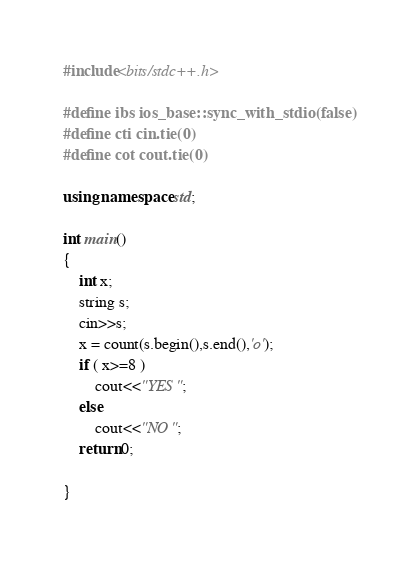<code> <loc_0><loc_0><loc_500><loc_500><_C++_>#include<bits/stdc++.h>

#define ibs ios_base::sync_with_stdio(false)
#define cti cin.tie(0)
#define cot cout.tie(0)

using namespace std;

int main()
{
    int x;
	string s;
    cin>>s;
    x = count(s.begin(),s.end(),'o');
    if ( x>=8 )
        cout<<"YES";
    else
        cout<<"NO";
	return 0;
	
}
</code> 